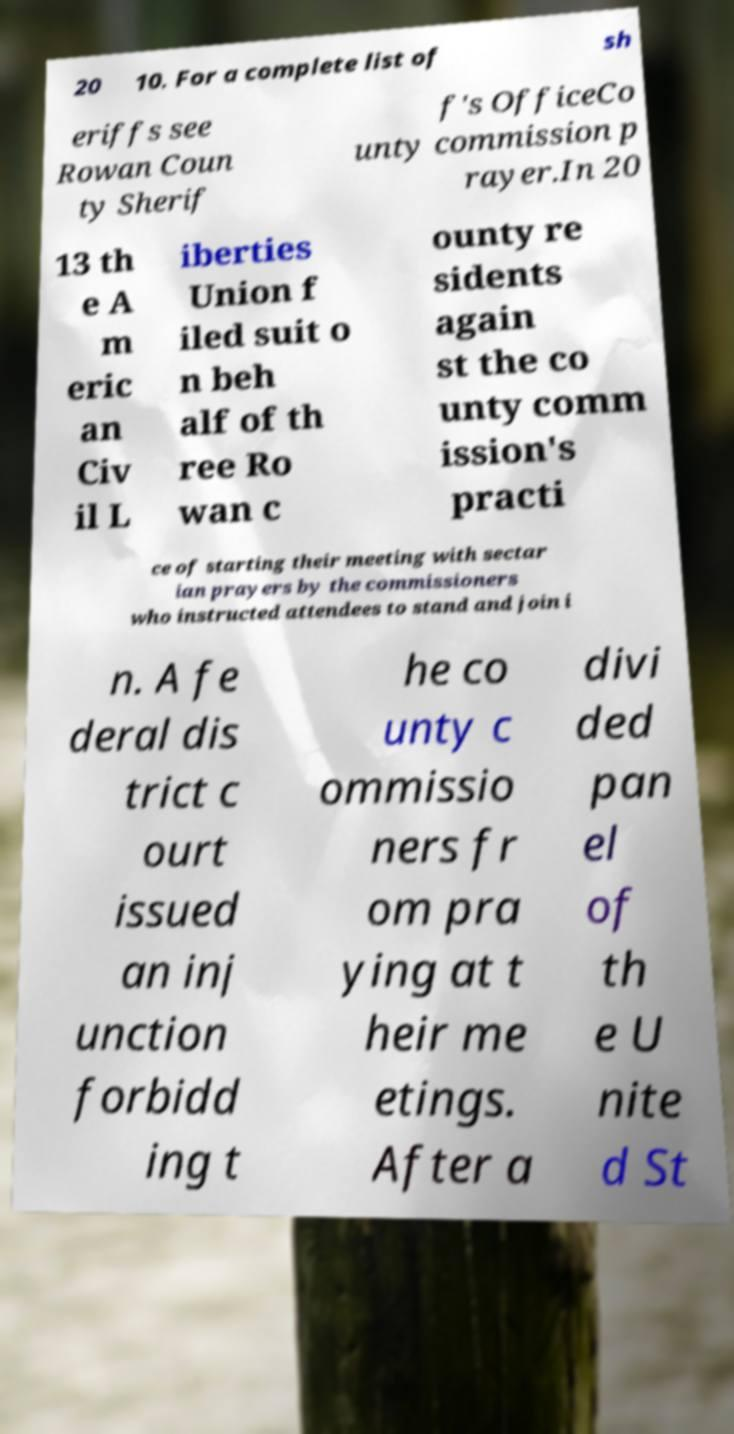Please read and relay the text visible in this image. What does it say? 20 10. For a complete list of sh eriffs see Rowan Coun ty Sherif f's OfficeCo unty commission p rayer.In 20 13 th e A m eric an Civ il L iberties Union f iled suit o n beh alf of th ree Ro wan c ounty re sidents again st the co unty comm ission's practi ce of starting their meeting with sectar ian prayers by the commissioners who instructed attendees to stand and join i n. A fe deral dis trict c ourt issued an inj unction forbidd ing t he co unty c ommissio ners fr om pra ying at t heir me etings. After a divi ded pan el of th e U nite d St 